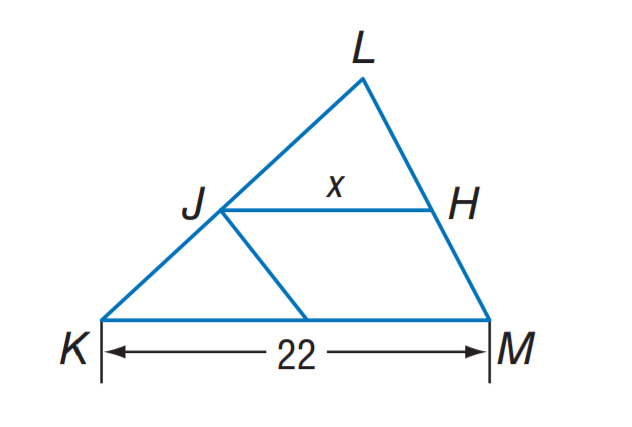Question: J H is a midsegment of \triangle K L M. Find x.
Choices:
A. 5
B. 10
C. 11
D. 22
Answer with the letter. Answer: C 